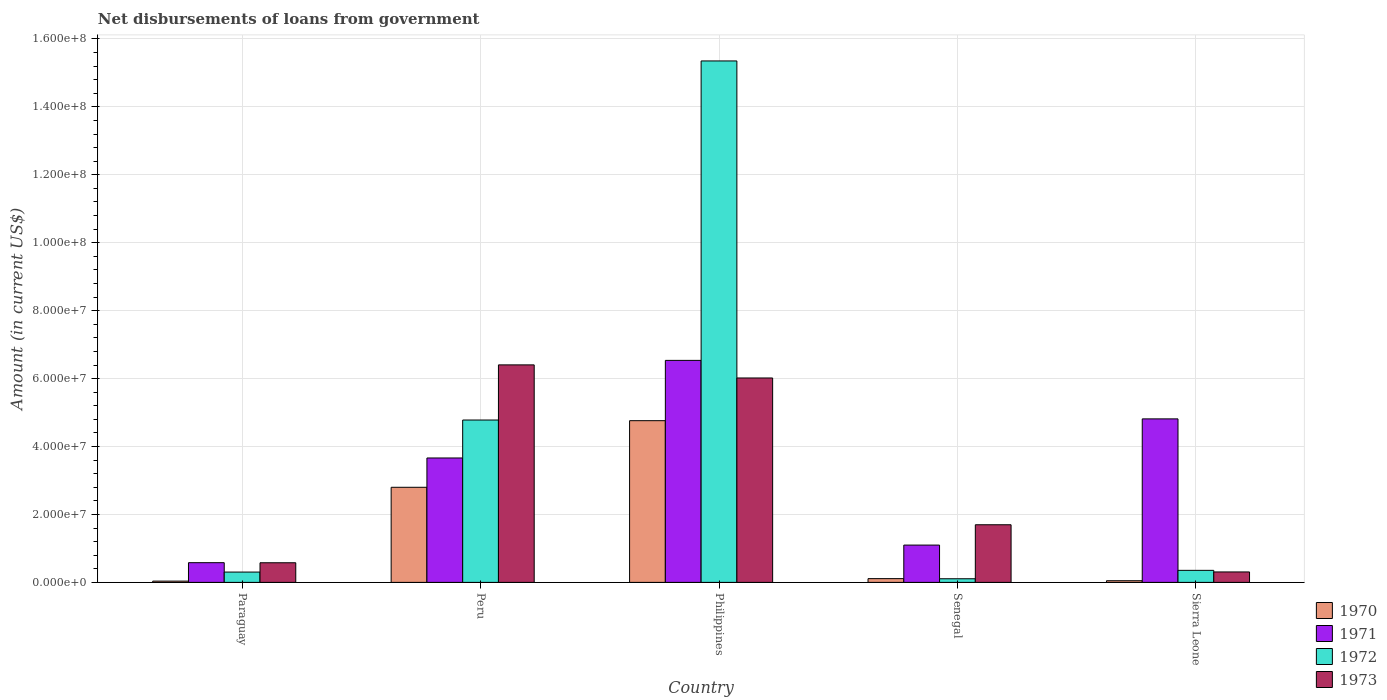How many groups of bars are there?
Make the answer very short. 5. Are the number of bars on each tick of the X-axis equal?
Your response must be concise. Yes. How many bars are there on the 4th tick from the left?
Make the answer very short. 4. What is the label of the 4th group of bars from the left?
Offer a terse response. Senegal. What is the amount of loan disbursed from government in 1973 in Peru?
Keep it short and to the point. 6.40e+07. Across all countries, what is the maximum amount of loan disbursed from government in 1973?
Your answer should be compact. 6.40e+07. Across all countries, what is the minimum amount of loan disbursed from government in 1972?
Offer a very short reply. 1.07e+06. In which country was the amount of loan disbursed from government in 1971 maximum?
Keep it short and to the point. Philippines. In which country was the amount of loan disbursed from government in 1972 minimum?
Offer a terse response. Senegal. What is the total amount of loan disbursed from government in 1973 in the graph?
Keep it short and to the point. 1.50e+08. What is the difference between the amount of loan disbursed from government in 1971 in Philippines and that in Senegal?
Your answer should be compact. 5.44e+07. What is the difference between the amount of loan disbursed from government in 1971 in Sierra Leone and the amount of loan disbursed from government in 1972 in Philippines?
Provide a short and direct response. -1.05e+08. What is the average amount of loan disbursed from government in 1973 per country?
Your response must be concise. 3.00e+07. What is the difference between the amount of loan disbursed from government of/in 1970 and amount of loan disbursed from government of/in 1973 in Peru?
Provide a succinct answer. -3.60e+07. In how many countries, is the amount of loan disbursed from government in 1971 greater than 48000000 US$?
Your answer should be very brief. 2. What is the ratio of the amount of loan disbursed from government in 1972 in Peru to that in Philippines?
Ensure brevity in your answer.  0.31. Is the amount of loan disbursed from government in 1972 in Paraguay less than that in Senegal?
Offer a terse response. No. Is the difference between the amount of loan disbursed from government in 1970 in Paraguay and Senegal greater than the difference between the amount of loan disbursed from government in 1973 in Paraguay and Senegal?
Your response must be concise. Yes. What is the difference between the highest and the second highest amount of loan disbursed from government in 1971?
Make the answer very short. 1.72e+07. What is the difference between the highest and the lowest amount of loan disbursed from government in 1970?
Make the answer very short. 4.72e+07. What does the 4th bar from the left in Peru represents?
Keep it short and to the point. 1973. Is it the case that in every country, the sum of the amount of loan disbursed from government in 1972 and amount of loan disbursed from government in 1971 is greater than the amount of loan disbursed from government in 1973?
Provide a short and direct response. No. Are all the bars in the graph horizontal?
Your answer should be compact. No. How many countries are there in the graph?
Offer a terse response. 5. Does the graph contain any zero values?
Ensure brevity in your answer.  No. Does the graph contain grids?
Provide a short and direct response. Yes. Where does the legend appear in the graph?
Your answer should be very brief. Bottom right. How are the legend labels stacked?
Provide a succinct answer. Vertical. What is the title of the graph?
Your answer should be very brief. Net disbursements of loans from government. Does "2000" appear as one of the legend labels in the graph?
Your response must be concise. No. What is the label or title of the X-axis?
Ensure brevity in your answer.  Country. What is the Amount (in current US$) in 1970 in Paraguay?
Provide a succinct answer. 3.74e+05. What is the Amount (in current US$) of 1971 in Paraguay?
Provide a succinct answer. 5.80e+06. What is the Amount (in current US$) of 1972 in Paraguay?
Keep it short and to the point. 3.04e+06. What is the Amount (in current US$) in 1973 in Paraguay?
Your answer should be very brief. 5.78e+06. What is the Amount (in current US$) in 1970 in Peru?
Offer a very short reply. 2.80e+07. What is the Amount (in current US$) in 1971 in Peru?
Offer a terse response. 3.66e+07. What is the Amount (in current US$) in 1972 in Peru?
Keep it short and to the point. 4.78e+07. What is the Amount (in current US$) of 1973 in Peru?
Your answer should be compact. 6.40e+07. What is the Amount (in current US$) in 1970 in Philippines?
Make the answer very short. 4.76e+07. What is the Amount (in current US$) of 1971 in Philippines?
Give a very brief answer. 6.54e+07. What is the Amount (in current US$) of 1972 in Philippines?
Ensure brevity in your answer.  1.54e+08. What is the Amount (in current US$) in 1973 in Philippines?
Your answer should be very brief. 6.02e+07. What is the Amount (in current US$) of 1970 in Senegal?
Provide a succinct answer. 1.11e+06. What is the Amount (in current US$) of 1971 in Senegal?
Your answer should be compact. 1.10e+07. What is the Amount (in current US$) in 1972 in Senegal?
Provide a short and direct response. 1.07e+06. What is the Amount (in current US$) in 1973 in Senegal?
Your response must be concise. 1.70e+07. What is the Amount (in current US$) of 1970 in Sierra Leone?
Give a very brief answer. 4.87e+05. What is the Amount (in current US$) in 1971 in Sierra Leone?
Provide a short and direct response. 4.81e+07. What is the Amount (in current US$) of 1972 in Sierra Leone?
Your answer should be compact. 3.54e+06. What is the Amount (in current US$) of 1973 in Sierra Leone?
Keep it short and to the point. 3.07e+06. Across all countries, what is the maximum Amount (in current US$) of 1970?
Offer a very short reply. 4.76e+07. Across all countries, what is the maximum Amount (in current US$) of 1971?
Ensure brevity in your answer.  6.54e+07. Across all countries, what is the maximum Amount (in current US$) in 1972?
Give a very brief answer. 1.54e+08. Across all countries, what is the maximum Amount (in current US$) of 1973?
Your response must be concise. 6.40e+07. Across all countries, what is the minimum Amount (in current US$) in 1970?
Give a very brief answer. 3.74e+05. Across all countries, what is the minimum Amount (in current US$) of 1971?
Your answer should be compact. 5.80e+06. Across all countries, what is the minimum Amount (in current US$) in 1972?
Make the answer very short. 1.07e+06. Across all countries, what is the minimum Amount (in current US$) of 1973?
Give a very brief answer. 3.07e+06. What is the total Amount (in current US$) in 1970 in the graph?
Provide a short and direct response. 7.76e+07. What is the total Amount (in current US$) of 1971 in the graph?
Provide a short and direct response. 1.67e+08. What is the total Amount (in current US$) in 1972 in the graph?
Ensure brevity in your answer.  2.09e+08. What is the total Amount (in current US$) in 1973 in the graph?
Offer a very short reply. 1.50e+08. What is the difference between the Amount (in current US$) of 1970 in Paraguay and that in Peru?
Your response must be concise. -2.76e+07. What is the difference between the Amount (in current US$) of 1971 in Paraguay and that in Peru?
Offer a very short reply. -3.08e+07. What is the difference between the Amount (in current US$) of 1972 in Paraguay and that in Peru?
Your answer should be compact. -4.48e+07. What is the difference between the Amount (in current US$) in 1973 in Paraguay and that in Peru?
Give a very brief answer. -5.83e+07. What is the difference between the Amount (in current US$) of 1970 in Paraguay and that in Philippines?
Offer a terse response. -4.72e+07. What is the difference between the Amount (in current US$) of 1971 in Paraguay and that in Philippines?
Your answer should be compact. -5.96e+07. What is the difference between the Amount (in current US$) of 1972 in Paraguay and that in Philippines?
Offer a very short reply. -1.50e+08. What is the difference between the Amount (in current US$) in 1973 in Paraguay and that in Philippines?
Ensure brevity in your answer.  -5.44e+07. What is the difference between the Amount (in current US$) of 1970 in Paraguay and that in Senegal?
Provide a short and direct response. -7.32e+05. What is the difference between the Amount (in current US$) in 1971 in Paraguay and that in Senegal?
Your answer should be very brief. -5.18e+06. What is the difference between the Amount (in current US$) in 1972 in Paraguay and that in Senegal?
Provide a succinct answer. 1.97e+06. What is the difference between the Amount (in current US$) of 1973 in Paraguay and that in Senegal?
Provide a succinct answer. -1.12e+07. What is the difference between the Amount (in current US$) in 1970 in Paraguay and that in Sierra Leone?
Offer a terse response. -1.13e+05. What is the difference between the Amount (in current US$) in 1971 in Paraguay and that in Sierra Leone?
Your response must be concise. -4.23e+07. What is the difference between the Amount (in current US$) in 1972 in Paraguay and that in Sierra Leone?
Provide a short and direct response. -5.07e+05. What is the difference between the Amount (in current US$) in 1973 in Paraguay and that in Sierra Leone?
Offer a very short reply. 2.70e+06. What is the difference between the Amount (in current US$) of 1970 in Peru and that in Philippines?
Your answer should be compact. -1.96e+07. What is the difference between the Amount (in current US$) in 1971 in Peru and that in Philippines?
Ensure brevity in your answer.  -2.87e+07. What is the difference between the Amount (in current US$) of 1972 in Peru and that in Philippines?
Your response must be concise. -1.06e+08. What is the difference between the Amount (in current US$) of 1973 in Peru and that in Philippines?
Provide a succinct answer. 3.86e+06. What is the difference between the Amount (in current US$) of 1970 in Peru and that in Senegal?
Offer a very short reply. 2.69e+07. What is the difference between the Amount (in current US$) of 1971 in Peru and that in Senegal?
Provide a succinct answer. 2.56e+07. What is the difference between the Amount (in current US$) in 1972 in Peru and that in Senegal?
Provide a short and direct response. 4.67e+07. What is the difference between the Amount (in current US$) of 1973 in Peru and that in Senegal?
Ensure brevity in your answer.  4.71e+07. What is the difference between the Amount (in current US$) in 1970 in Peru and that in Sierra Leone?
Provide a succinct answer. 2.75e+07. What is the difference between the Amount (in current US$) in 1971 in Peru and that in Sierra Leone?
Provide a short and direct response. -1.15e+07. What is the difference between the Amount (in current US$) of 1972 in Peru and that in Sierra Leone?
Keep it short and to the point. 4.43e+07. What is the difference between the Amount (in current US$) in 1973 in Peru and that in Sierra Leone?
Make the answer very short. 6.10e+07. What is the difference between the Amount (in current US$) of 1970 in Philippines and that in Senegal?
Keep it short and to the point. 4.65e+07. What is the difference between the Amount (in current US$) of 1971 in Philippines and that in Senegal?
Your answer should be very brief. 5.44e+07. What is the difference between the Amount (in current US$) of 1972 in Philippines and that in Senegal?
Make the answer very short. 1.52e+08. What is the difference between the Amount (in current US$) in 1973 in Philippines and that in Senegal?
Your answer should be very brief. 4.32e+07. What is the difference between the Amount (in current US$) of 1970 in Philippines and that in Sierra Leone?
Give a very brief answer. 4.71e+07. What is the difference between the Amount (in current US$) of 1971 in Philippines and that in Sierra Leone?
Provide a succinct answer. 1.72e+07. What is the difference between the Amount (in current US$) in 1972 in Philippines and that in Sierra Leone?
Your answer should be compact. 1.50e+08. What is the difference between the Amount (in current US$) in 1973 in Philippines and that in Sierra Leone?
Your response must be concise. 5.71e+07. What is the difference between the Amount (in current US$) of 1970 in Senegal and that in Sierra Leone?
Your answer should be very brief. 6.19e+05. What is the difference between the Amount (in current US$) in 1971 in Senegal and that in Sierra Leone?
Give a very brief answer. -3.72e+07. What is the difference between the Amount (in current US$) of 1972 in Senegal and that in Sierra Leone?
Your response must be concise. -2.48e+06. What is the difference between the Amount (in current US$) in 1973 in Senegal and that in Sierra Leone?
Keep it short and to the point. 1.39e+07. What is the difference between the Amount (in current US$) in 1970 in Paraguay and the Amount (in current US$) in 1971 in Peru?
Your answer should be very brief. -3.63e+07. What is the difference between the Amount (in current US$) in 1970 in Paraguay and the Amount (in current US$) in 1972 in Peru?
Ensure brevity in your answer.  -4.74e+07. What is the difference between the Amount (in current US$) of 1970 in Paraguay and the Amount (in current US$) of 1973 in Peru?
Your response must be concise. -6.37e+07. What is the difference between the Amount (in current US$) of 1971 in Paraguay and the Amount (in current US$) of 1972 in Peru?
Offer a very short reply. -4.20e+07. What is the difference between the Amount (in current US$) of 1971 in Paraguay and the Amount (in current US$) of 1973 in Peru?
Provide a succinct answer. -5.82e+07. What is the difference between the Amount (in current US$) in 1972 in Paraguay and the Amount (in current US$) in 1973 in Peru?
Make the answer very short. -6.10e+07. What is the difference between the Amount (in current US$) of 1970 in Paraguay and the Amount (in current US$) of 1971 in Philippines?
Offer a very short reply. -6.50e+07. What is the difference between the Amount (in current US$) of 1970 in Paraguay and the Amount (in current US$) of 1972 in Philippines?
Ensure brevity in your answer.  -1.53e+08. What is the difference between the Amount (in current US$) in 1970 in Paraguay and the Amount (in current US$) in 1973 in Philippines?
Your response must be concise. -5.98e+07. What is the difference between the Amount (in current US$) of 1971 in Paraguay and the Amount (in current US$) of 1972 in Philippines?
Provide a succinct answer. -1.48e+08. What is the difference between the Amount (in current US$) of 1971 in Paraguay and the Amount (in current US$) of 1973 in Philippines?
Keep it short and to the point. -5.44e+07. What is the difference between the Amount (in current US$) of 1972 in Paraguay and the Amount (in current US$) of 1973 in Philippines?
Give a very brief answer. -5.71e+07. What is the difference between the Amount (in current US$) in 1970 in Paraguay and the Amount (in current US$) in 1971 in Senegal?
Keep it short and to the point. -1.06e+07. What is the difference between the Amount (in current US$) of 1970 in Paraguay and the Amount (in current US$) of 1972 in Senegal?
Keep it short and to the point. -6.92e+05. What is the difference between the Amount (in current US$) of 1970 in Paraguay and the Amount (in current US$) of 1973 in Senegal?
Your answer should be very brief. -1.66e+07. What is the difference between the Amount (in current US$) in 1971 in Paraguay and the Amount (in current US$) in 1972 in Senegal?
Keep it short and to the point. 4.74e+06. What is the difference between the Amount (in current US$) of 1971 in Paraguay and the Amount (in current US$) of 1973 in Senegal?
Provide a short and direct response. -1.12e+07. What is the difference between the Amount (in current US$) of 1972 in Paraguay and the Amount (in current US$) of 1973 in Senegal?
Offer a very short reply. -1.39e+07. What is the difference between the Amount (in current US$) of 1970 in Paraguay and the Amount (in current US$) of 1971 in Sierra Leone?
Provide a short and direct response. -4.78e+07. What is the difference between the Amount (in current US$) of 1970 in Paraguay and the Amount (in current US$) of 1972 in Sierra Leone?
Provide a short and direct response. -3.17e+06. What is the difference between the Amount (in current US$) in 1970 in Paraguay and the Amount (in current US$) in 1973 in Sierra Leone?
Your response must be concise. -2.70e+06. What is the difference between the Amount (in current US$) of 1971 in Paraguay and the Amount (in current US$) of 1972 in Sierra Leone?
Provide a succinct answer. 2.26e+06. What is the difference between the Amount (in current US$) of 1971 in Paraguay and the Amount (in current US$) of 1973 in Sierra Leone?
Make the answer very short. 2.73e+06. What is the difference between the Amount (in current US$) of 1972 in Paraguay and the Amount (in current US$) of 1973 in Sierra Leone?
Provide a succinct answer. -3.80e+04. What is the difference between the Amount (in current US$) in 1970 in Peru and the Amount (in current US$) in 1971 in Philippines?
Your response must be concise. -3.74e+07. What is the difference between the Amount (in current US$) in 1970 in Peru and the Amount (in current US$) in 1972 in Philippines?
Offer a terse response. -1.26e+08. What is the difference between the Amount (in current US$) in 1970 in Peru and the Amount (in current US$) in 1973 in Philippines?
Provide a short and direct response. -3.22e+07. What is the difference between the Amount (in current US$) of 1971 in Peru and the Amount (in current US$) of 1972 in Philippines?
Your answer should be compact. -1.17e+08. What is the difference between the Amount (in current US$) of 1971 in Peru and the Amount (in current US$) of 1973 in Philippines?
Keep it short and to the point. -2.36e+07. What is the difference between the Amount (in current US$) of 1972 in Peru and the Amount (in current US$) of 1973 in Philippines?
Ensure brevity in your answer.  -1.24e+07. What is the difference between the Amount (in current US$) in 1970 in Peru and the Amount (in current US$) in 1971 in Senegal?
Your response must be concise. 1.70e+07. What is the difference between the Amount (in current US$) in 1970 in Peru and the Amount (in current US$) in 1972 in Senegal?
Provide a succinct answer. 2.69e+07. What is the difference between the Amount (in current US$) of 1970 in Peru and the Amount (in current US$) of 1973 in Senegal?
Ensure brevity in your answer.  1.10e+07. What is the difference between the Amount (in current US$) in 1971 in Peru and the Amount (in current US$) in 1972 in Senegal?
Provide a succinct answer. 3.56e+07. What is the difference between the Amount (in current US$) of 1971 in Peru and the Amount (in current US$) of 1973 in Senegal?
Offer a terse response. 1.97e+07. What is the difference between the Amount (in current US$) of 1972 in Peru and the Amount (in current US$) of 1973 in Senegal?
Ensure brevity in your answer.  3.08e+07. What is the difference between the Amount (in current US$) in 1970 in Peru and the Amount (in current US$) in 1971 in Sierra Leone?
Provide a succinct answer. -2.01e+07. What is the difference between the Amount (in current US$) of 1970 in Peru and the Amount (in current US$) of 1972 in Sierra Leone?
Provide a short and direct response. 2.45e+07. What is the difference between the Amount (in current US$) of 1970 in Peru and the Amount (in current US$) of 1973 in Sierra Leone?
Your answer should be compact. 2.49e+07. What is the difference between the Amount (in current US$) of 1971 in Peru and the Amount (in current US$) of 1972 in Sierra Leone?
Keep it short and to the point. 3.31e+07. What is the difference between the Amount (in current US$) of 1971 in Peru and the Amount (in current US$) of 1973 in Sierra Leone?
Offer a very short reply. 3.36e+07. What is the difference between the Amount (in current US$) of 1972 in Peru and the Amount (in current US$) of 1973 in Sierra Leone?
Your response must be concise. 4.47e+07. What is the difference between the Amount (in current US$) of 1970 in Philippines and the Amount (in current US$) of 1971 in Senegal?
Offer a terse response. 3.66e+07. What is the difference between the Amount (in current US$) in 1970 in Philippines and the Amount (in current US$) in 1972 in Senegal?
Provide a short and direct response. 4.65e+07. What is the difference between the Amount (in current US$) in 1970 in Philippines and the Amount (in current US$) in 1973 in Senegal?
Ensure brevity in your answer.  3.06e+07. What is the difference between the Amount (in current US$) in 1971 in Philippines and the Amount (in current US$) in 1972 in Senegal?
Your response must be concise. 6.43e+07. What is the difference between the Amount (in current US$) of 1971 in Philippines and the Amount (in current US$) of 1973 in Senegal?
Keep it short and to the point. 4.84e+07. What is the difference between the Amount (in current US$) of 1972 in Philippines and the Amount (in current US$) of 1973 in Senegal?
Provide a succinct answer. 1.37e+08. What is the difference between the Amount (in current US$) of 1970 in Philippines and the Amount (in current US$) of 1971 in Sierra Leone?
Offer a very short reply. -5.32e+05. What is the difference between the Amount (in current US$) of 1970 in Philippines and the Amount (in current US$) of 1972 in Sierra Leone?
Keep it short and to the point. 4.41e+07. What is the difference between the Amount (in current US$) of 1970 in Philippines and the Amount (in current US$) of 1973 in Sierra Leone?
Your answer should be very brief. 4.45e+07. What is the difference between the Amount (in current US$) in 1971 in Philippines and the Amount (in current US$) in 1972 in Sierra Leone?
Provide a succinct answer. 6.18e+07. What is the difference between the Amount (in current US$) of 1971 in Philippines and the Amount (in current US$) of 1973 in Sierra Leone?
Provide a succinct answer. 6.23e+07. What is the difference between the Amount (in current US$) in 1972 in Philippines and the Amount (in current US$) in 1973 in Sierra Leone?
Give a very brief answer. 1.50e+08. What is the difference between the Amount (in current US$) of 1970 in Senegal and the Amount (in current US$) of 1971 in Sierra Leone?
Provide a short and direct response. -4.70e+07. What is the difference between the Amount (in current US$) in 1970 in Senegal and the Amount (in current US$) in 1972 in Sierra Leone?
Provide a succinct answer. -2.44e+06. What is the difference between the Amount (in current US$) of 1970 in Senegal and the Amount (in current US$) of 1973 in Sierra Leone?
Ensure brevity in your answer.  -1.97e+06. What is the difference between the Amount (in current US$) of 1971 in Senegal and the Amount (in current US$) of 1972 in Sierra Leone?
Make the answer very short. 7.44e+06. What is the difference between the Amount (in current US$) of 1971 in Senegal and the Amount (in current US$) of 1973 in Sierra Leone?
Provide a succinct answer. 7.90e+06. What is the difference between the Amount (in current US$) in 1972 in Senegal and the Amount (in current US$) in 1973 in Sierra Leone?
Offer a terse response. -2.01e+06. What is the average Amount (in current US$) in 1970 per country?
Your response must be concise. 1.55e+07. What is the average Amount (in current US$) of 1971 per country?
Your response must be concise. 3.34e+07. What is the average Amount (in current US$) in 1972 per country?
Keep it short and to the point. 4.18e+07. What is the average Amount (in current US$) of 1973 per country?
Offer a very short reply. 3.00e+07. What is the difference between the Amount (in current US$) in 1970 and Amount (in current US$) in 1971 in Paraguay?
Offer a very short reply. -5.43e+06. What is the difference between the Amount (in current US$) of 1970 and Amount (in current US$) of 1972 in Paraguay?
Ensure brevity in your answer.  -2.66e+06. What is the difference between the Amount (in current US$) in 1970 and Amount (in current US$) in 1973 in Paraguay?
Your answer should be compact. -5.40e+06. What is the difference between the Amount (in current US$) in 1971 and Amount (in current US$) in 1972 in Paraguay?
Offer a very short reply. 2.77e+06. What is the difference between the Amount (in current US$) of 1971 and Amount (in current US$) of 1973 in Paraguay?
Offer a very short reply. 2.50e+04. What is the difference between the Amount (in current US$) of 1972 and Amount (in current US$) of 1973 in Paraguay?
Offer a very short reply. -2.74e+06. What is the difference between the Amount (in current US$) of 1970 and Amount (in current US$) of 1971 in Peru?
Offer a very short reply. -8.63e+06. What is the difference between the Amount (in current US$) in 1970 and Amount (in current US$) in 1972 in Peru?
Offer a terse response. -1.98e+07. What is the difference between the Amount (in current US$) of 1970 and Amount (in current US$) of 1973 in Peru?
Your response must be concise. -3.60e+07. What is the difference between the Amount (in current US$) of 1971 and Amount (in current US$) of 1972 in Peru?
Provide a short and direct response. -1.12e+07. What is the difference between the Amount (in current US$) in 1971 and Amount (in current US$) in 1973 in Peru?
Offer a terse response. -2.74e+07. What is the difference between the Amount (in current US$) of 1972 and Amount (in current US$) of 1973 in Peru?
Make the answer very short. -1.62e+07. What is the difference between the Amount (in current US$) of 1970 and Amount (in current US$) of 1971 in Philippines?
Offer a terse response. -1.78e+07. What is the difference between the Amount (in current US$) in 1970 and Amount (in current US$) in 1972 in Philippines?
Keep it short and to the point. -1.06e+08. What is the difference between the Amount (in current US$) in 1970 and Amount (in current US$) in 1973 in Philippines?
Provide a short and direct response. -1.26e+07. What is the difference between the Amount (in current US$) of 1971 and Amount (in current US$) of 1972 in Philippines?
Provide a succinct answer. -8.82e+07. What is the difference between the Amount (in current US$) of 1971 and Amount (in current US$) of 1973 in Philippines?
Your answer should be compact. 5.18e+06. What is the difference between the Amount (in current US$) in 1972 and Amount (in current US$) in 1973 in Philippines?
Your answer should be compact. 9.33e+07. What is the difference between the Amount (in current US$) in 1970 and Amount (in current US$) in 1971 in Senegal?
Offer a terse response. -9.87e+06. What is the difference between the Amount (in current US$) of 1970 and Amount (in current US$) of 1972 in Senegal?
Provide a succinct answer. 4.00e+04. What is the difference between the Amount (in current US$) of 1970 and Amount (in current US$) of 1973 in Senegal?
Provide a short and direct response. -1.59e+07. What is the difference between the Amount (in current US$) in 1971 and Amount (in current US$) in 1972 in Senegal?
Provide a succinct answer. 9.91e+06. What is the difference between the Amount (in current US$) in 1971 and Amount (in current US$) in 1973 in Senegal?
Ensure brevity in your answer.  -5.99e+06. What is the difference between the Amount (in current US$) of 1972 and Amount (in current US$) of 1973 in Senegal?
Provide a short and direct response. -1.59e+07. What is the difference between the Amount (in current US$) of 1970 and Amount (in current US$) of 1971 in Sierra Leone?
Your answer should be compact. -4.77e+07. What is the difference between the Amount (in current US$) in 1970 and Amount (in current US$) in 1972 in Sierra Leone?
Offer a terse response. -3.06e+06. What is the difference between the Amount (in current US$) in 1970 and Amount (in current US$) in 1973 in Sierra Leone?
Offer a terse response. -2.59e+06. What is the difference between the Amount (in current US$) of 1971 and Amount (in current US$) of 1972 in Sierra Leone?
Your answer should be compact. 4.46e+07. What is the difference between the Amount (in current US$) of 1971 and Amount (in current US$) of 1973 in Sierra Leone?
Provide a short and direct response. 4.51e+07. What is the difference between the Amount (in current US$) in 1972 and Amount (in current US$) in 1973 in Sierra Leone?
Your response must be concise. 4.69e+05. What is the ratio of the Amount (in current US$) in 1970 in Paraguay to that in Peru?
Your response must be concise. 0.01. What is the ratio of the Amount (in current US$) in 1971 in Paraguay to that in Peru?
Offer a very short reply. 0.16. What is the ratio of the Amount (in current US$) of 1972 in Paraguay to that in Peru?
Your answer should be very brief. 0.06. What is the ratio of the Amount (in current US$) in 1973 in Paraguay to that in Peru?
Provide a short and direct response. 0.09. What is the ratio of the Amount (in current US$) of 1970 in Paraguay to that in Philippines?
Provide a succinct answer. 0.01. What is the ratio of the Amount (in current US$) of 1971 in Paraguay to that in Philippines?
Provide a short and direct response. 0.09. What is the ratio of the Amount (in current US$) of 1972 in Paraguay to that in Philippines?
Keep it short and to the point. 0.02. What is the ratio of the Amount (in current US$) in 1973 in Paraguay to that in Philippines?
Your answer should be very brief. 0.1. What is the ratio of the Amount (in current US$) of 1970 in Paraguay to that in Senegal?
Provide a succinct answer. 0.34. What is the ratio of the Amount (in current US$) in 1971 in Paraguay to that in Senegal?
Provide a short and direct response. 0.53. What is the ratio of the Amount (in current US$) of 1972 in Paraguay to that in Senegal?
Your answer should be compact. 2.85. What is the ratio of the Amount (in current US$) in 1973 in Paraguay to that in Senegal?
Provide a short and direct response. 0.34. What is the ratio of the Amount (in current US$) of 1970 in Paraguay to that in Sierra Leone?
Your response must be concise. 0.77. What is the ratio of the Amount (in current US$) in 1971 in Paraguay to that in Sierra Leone?
Offer a terse response. 0.12. What is the ratio of the Amount (in current US$) in 1972 in Paraguay to that in Sierra Leone?
Provide a short and direct response. 0.86. What is the ratio of the Amount (in current US$) of 1973 in Paraguay to that in Sierra Leone?
Provide a short and direct response. 1.88. What is the ratio of the Amount (in current US$) in 1970 in Peru to that in Philippines?
Give a very brief answer. 0.59. What is the ratio of the Amount (in current US$) in 1971 in Peru to that in Philippines?
Give a very brief answer. 0.56. What is the ratio of the Amount (in current US$) of 1972 in Peru to that in Philippines?
Ensure brevity in your answer.  0.31. What is the ratio of the Amount (in current US$) in 1973 in Peru to that in Philippines?
Keep it short and to the point. 1.06. What is the ratio of the Amount (in current US$) in 1970 in Peru to that in Senegal?
Offer a very short reply. 25.31. What is the ratio of the Amount (in current US$) in 1971 in Peru to that in Senegal?
Keep it short and to the point. 3.34. What is the ratio of the Amount (in current US$) in 1972 in Peru to that in Senegal?
Ensure brevity in your answer.  44.84. What is the ratio of the Amount (in current US$) in 1973 in Peru to that in Senegal?
Your response must be concise. 3.77. What is the ratio of the Amount (in current US$) in 1970 in Peru to that in Sierra Leone?
Your response must be concise. 57.49. What is the ratio of the Amount (in current US$) of 1971 in Peru to that in Sierra Leone?
Give a very brief answer. 0.76. What is the ratio of the Amount (in current US$) in 1972 in Peru to that in Sierra Leone?
Keep it short and to the point. 13.49. What is the ratio of the Amount (in current US$) in 1973 in Peru to that in Sierra Leone?
Your answer should be very brief. 20.83. What is the ratio of the Amount (in current US$) in 1970 in Philippines to that in Senegal?
Your response must be concise. 43.04. What is the ratio of the Amount (in current US$) of 1971 in Philippines to that in Senegal?
Your answer should be compact. 5.95. What is the ratio of the Amount (in current US$) in 1972 in Philippines to that in Senegal?
Your answer should be compact. 144.01. What is the ratio of the Amount (in current US$) of 1973 in Philippines to that in Senegal?
Give a very brief answer. 3.55. What is the ratio of the Amount (in current US$) of 1970 in Philippines to that in Sierra Leone?
Your answer should be compact. 97.75. What is the ratio of the Amount (in current US$) in 1971 in Philippines to that in Sierra Leone?
Your answer should be very brief. 1.36. What is the ratio of the Amount (in current US$) of 1972 in Philippines to that in Sierra Leone?
Your answer should be very brief. 43.33. What is the ratio of the Amount (in current US$) of 1973 in Philippines to that in Sierra Leone?
Ensure brevity in your answer.  19.58. What is the ratio of the Amount (in current US$) in 1970 in Senegal to that in Sierra Leone?
Provide a short and direct response. 2.27. What is the ratio of the Amount (in current US$) in 1971 in Senegal to that in Sierra Leone?
Keep it short and to the point. 0.23. What is the ratio of the Amount (in current US$) of 1972 in Senegal to that in Sierra Leone?
Provide a short and direct response. 0.3. What is the ratio of the Amount (in current US$) of 1973 in Senegal to that in Sierra Leone?
Make the answer very short. 5.52. What is the difference between the highest and the second highest Amount (in current US$) of 1970?
Keep it short and to the point. 1.96e+07. What is the difference between the highest and the second highest Amount (in current US$) in 1971?
Provide a short and direct response. 1.72e+07. What is the difference between the highest and the second highest Amount (in current US$) in 1972?
Ensure brevity in your answer.  1.06e+08. What is the difference between the highest and the second highest Amount (in current US$) of 1973?
Give a very brief answer. 3.86e+06. What is the difference between the highest and the lowest Amount (in current US$) in 1970?
Ensure brevity in your answer.  4.72e+07. What is the difference between the highest and the lowest Amount (in current US$) in 1971?
Your answer should be compact. 5.96e+07. What is the difference between the highest and the lowest Amount (in current US$) in 1972?
Make the answer very short. 1.52e+08. What is the difference between the highest and the lowest Amount (in current US$) in 1973?
Ensure brevity in your answer.  6.10e+07. 